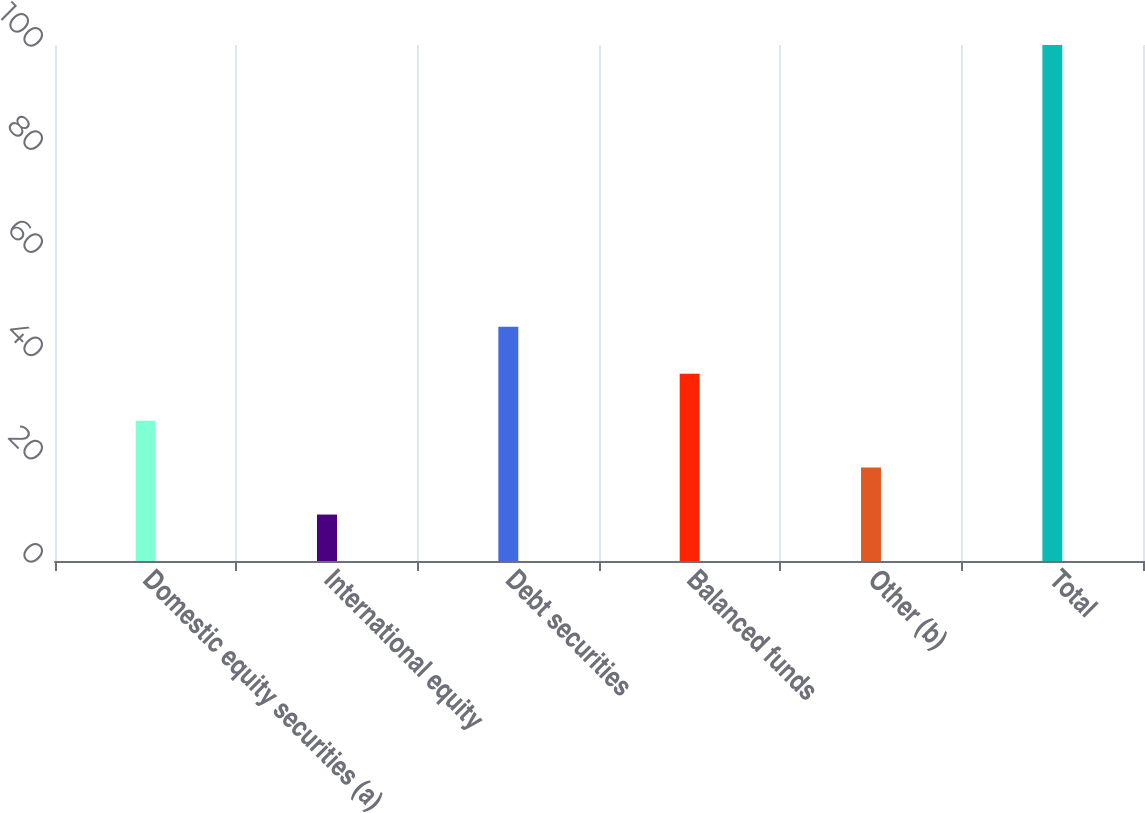Convert chart. <chart><loc_0><loc_0><loc_500><loc_500><bar_chart><fcel>Domestic equity securities (a)<fcel>International equity<fcel>Debt securities<fcel>Balanced funds<fcel>Other (b)<fcel>Total<nl><fcel>27.2<fcel>9<fcel>45.4<fcel>36.3<fcel>18.1<fcel>100<nl></chart> 